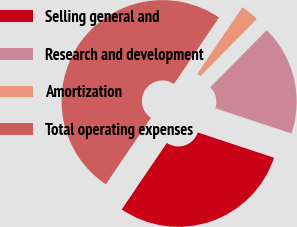Convert chart to OTSL. <chart><loc_0><loc_0><loc_500><loc_500><pie_chart><fcel>Selling general and<fcel>Research and development<fcel>Amortization<fcel>Total operating expenses<nl><fcel>29.39%<fcel>17.68%<fcel>2.93%<fcel>50.0%<nl></chart> 